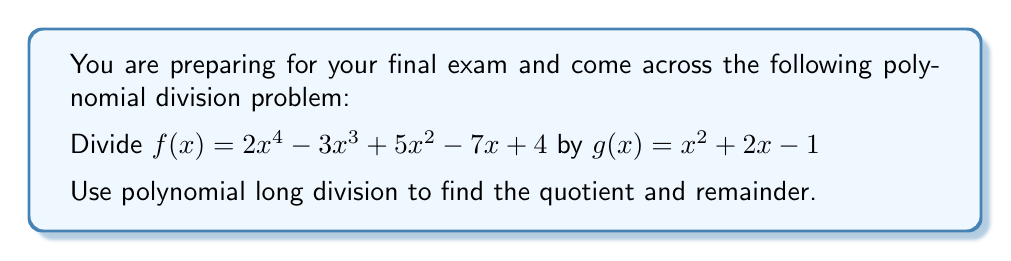Solve this math problem. Let's perform polynomial long division step by step:

1) Set up the division:

   $$\frac{2x^4 - 3x^3 + 5x^2 - 7x + 4}{x^2 + 2x - 1}$$

2) Divide $2x^4$ by $x^2$, which gives $2x^2$. This is the first term of our quotient.

3) Multiply $(x^2 + 2x - 1)$ by $2x^2$:
   $2x^4 + 4x^3 - 2x^2$

4) Subtract this from the dividend:
   $2x^4 - 3x^3 + 5x^2 - 7x + 4$
   $-(2x^4 + 4x^3 - 2x^2)$
   $= -7x^3 + 7x^2 - 7x + 4$

5) Bring down the remaining terms. Now divide $-7x^3$ by $x^2$, which gives $-7x$. This is the second term of our quotient.

6) Multiply $(x^2 + 2x - 1)$ by $-7x$:
   $-7x^3 - 14x^2 + 7x$

7) Subtract:
   $-7x^3 + 7x^2 - 7x + 4$
   $-(-7x^3 - 14x^2 + 7x)$
   $= 21x^2 - 14x + 4$

8) Divide $21x^2$ by $x^2$, which gives $21$. This is the last term of our quotient.

9) Multiply $(x^2 + 2x - 1)$ by $21$:
   $21x^2 + 42x - 21$

10) Subtract:
    $21x^2 - 14x + 4$
    $-(21x^2 + 42x - 21)$
    $= -56x + 25$

The division process ends here as the degree of $-56x + 25$ is less than the degree of $x^2 + 2x - 1$.

Therefore, the quotient is $2x^2 - 7x + 21$ and the remainder is $-56x + 25$.
Answer: Quotient: $2x^2 - 7x + 21$
Remainder: $-56x + 25$ 